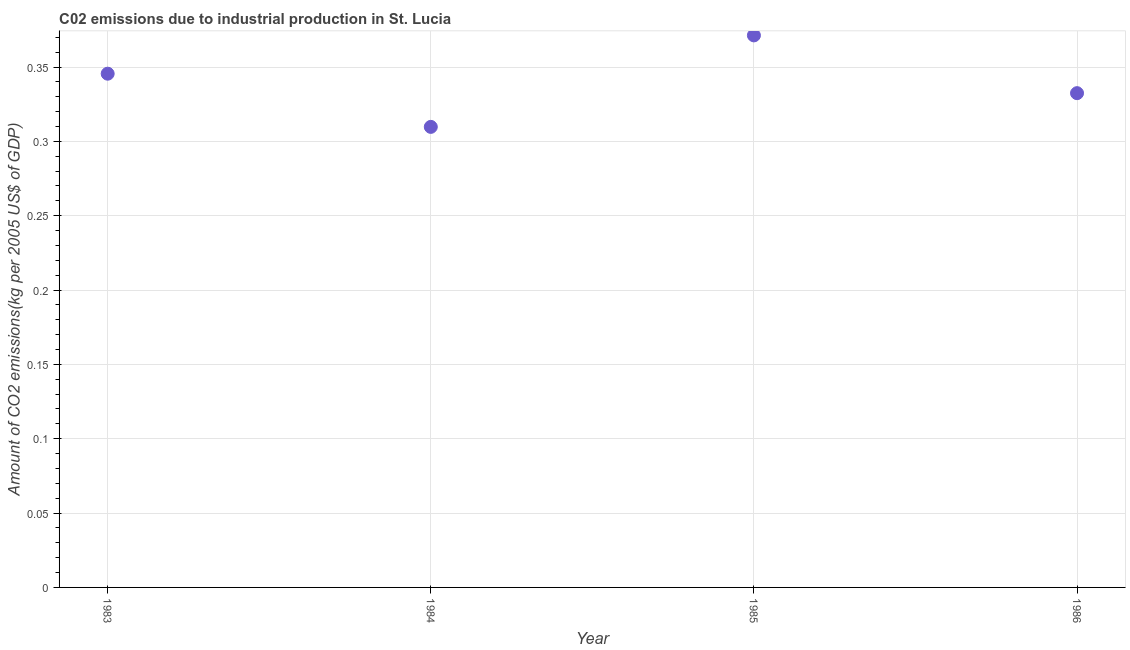What is the amount of co2 emissions in 1985?
Your response must be concise. 0.37. Across all years, what is the maximum amount of co2 emissions?
Keep it short and to the point. 0.37. Across all years, what is the minimum amount of co2 emissions?
Offer a very short reply. 0.31. In which year was the amount of co2 emissions maximum?
Your answer should be compact. 1985. What is the sum of the amount of co2 emissions?
Offer a terse response. 1.36. What is the difference between the amount of co2 emissions in 1983 and 1984?
Provide a short and direct response. 0.04. What is the average amount of co2 emissions per year?
Ensure brevity in your answer.  0.34. What is the median amount of co2 emissions?
Keep it short and to the point. 0.34. In how many years, is the amount of co2 emissions greater than 0.36000000000000004 kg per 2005 US$ of GDP?
Provide a short and direct response. 1. Do a majority of the years between 1985 and 1984 (inclusive) have amount of co2 emissions greater than 0.33000000000000007 kg per 2005 US$ of GDP?
Give a very brief answer. No. What is the ratio of the amount of co2 emissions in 1983 to that in 1986?
Offer a terse response. 1.04. Is the amount of co2 emissions in 1983 less than that in 1986?
Give a very brief answer. No. Is the difference between the amount of co2 emissions in 1984 and 1986 greater than the difference between any two years?
Keep it short and to the point. No. What is the difference between the highest and the second highest amount of co2 emissions?
Your response must be concise. 0.03. Is the sum of the amount of co2 emissions in 1983 and 1985 greater than the maximum amount of co2 emissions across all years?
Make the answer very short. Yes. What is the difference between the highest and the lowest amount of co2 emissions?
Your answer should be compact. 0.06. In how many years, is the amount of co2 emissions greater than the average amount of co2 emissions taken over all years?
Keep it short and to the point. 2. Does the amount of co2 emissions monotonically increase over the years?
Offer a terse response. No. How many years are there in the graph?
Provide a succinct answer. 4. What is the difference between two consecutive major ticks on the Y-axis?
Your answer should be very brief. 0.05. Does the graph contain any zero values?
Provide a short and direct response. No. What is the title of the graph?
Provide a short and direct response. C02 emissions due to industrial production in St. Lucia. What is the label or title of the X-axis?
Give a very brief answer. Year. What is the label or title of the Y-axis?
Keep it short and to the point. Amount of CO2 emissions(kg per 2005 US$ of GDP). What is the Amount of CO2 emissions(kg per 2005 US$ of GDP) in 1983?
Offer a terse response. 0.35. What is the Amount of CO2 emissions(kg per 2005 US$ of GDP) in 1984?
Offer a very short reply. 0.31. What is the Amount of CO2 emissions(kg per 2005 US$ of GDP) in 1985?
Keep it short and to the point. 0.37. What is the Amount of CO2 emissions(kg per 2005 US$ of GDP) in 1986?
Your answer should be compact. 0.33. What is the difference between the Amount of CO2 emissions(kg per 2005 US$ of GDP) in 1983 and 1984?
Your response must be concise. 0.04. What is the difference between the Amount of CO2 emissions(kg per 2005 US$ of GDP) in 1983 and 1985?
Offer a very short reply. -0.03. What is the difference between the Amount of CO2 emissions(kg per 2005 US$ of GDP) in 1983 and 1986?
Provide a short and direct response. 0.01. What is the difference between the Amount of CO2 emissions(kg per 2005 US$ of GDP) in 1984 and 1985?
Make the answer very short. -0.06. What is the difference between the Amount of CO2 emissions(kg per 2005 US$ of GDP) in 1984 and 1986?
Your answer should be very brief. -0.02. What is the difference between the Amount of CO2 emissions(kg per 2005 US$ of GDP) in 1985 and 1986?
Your answer should be very brief. 0.04. What is the ratio of the Amount of CO2 emissions(kg per 2005 US$ of GDP) in 1983 to that in 1984?
Your answer should be very brief. 1.12. What is the ratio of the Amount of CO2 emissions(kg per 2005 US$ of GDP) in 1983 to that in 1986?
Ensure brevity in your answer.  1.04. What is the ratio of the Amount of CO2 emissions(kg per 2005 US$ of GDP) in 1984 to that in 1985?
Your response must be concise. 0.83. What is the ratio of the Amount of CO2 emissions(kg per 2005 US$ of GDP) in 1984 to that in 1986?
Ensure brevity in your answer.  0.93. What is the ratio of the Amount of CO2 emissions(kg per 2005 US$ of GDP) in 1985 to that in 1986?
Provide a succinct answer. 1.12. 